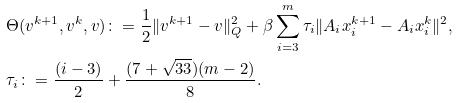<formula> <loc_0><loc_0><loc_500><loc_500>& \Theta ( v ^ { k + 1 } , v ^ { k } , v ) \colon = \frac { 1 } { 2 } \| v ^ { k + 1 } - v \| _ { Q } ^ { 2 } + \beta \sum _ { i = 3 } ^ { m } \tau _ { i } \| A _ { i } x _ { i } ^ { k + 1 } - A _ { i } x _ { i } ^ { k } \| ^ { 2 } , \, \\ & \tau _ { i } \colon = \frac { ( i - 3 ) } { 2 } + \frac { ( 7 + \sqrt { 3 3 } ) ( m - 2 ) } { 8 } .</formula> 